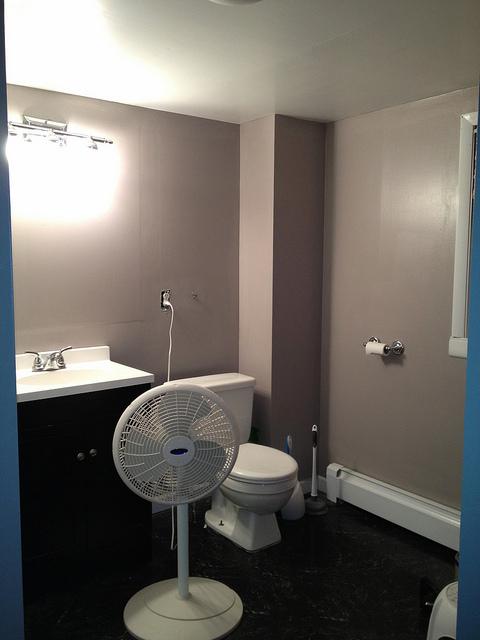Is this in the woods?
Quick response, please. No. Is there a plunger?
Answer briefly. Yes. Why is there a fan in the restroom?
Be succinct. In case it needs to air out. How many lights are there?
Short answer required. 1. How many windows are in the picture?
Short answer required. 0. Is the toilet seat up?
Short answer required. No. Is there a person in the room?
Answer briefly. No. Is there a hardwood floor?
Answer briefly. Yes. 